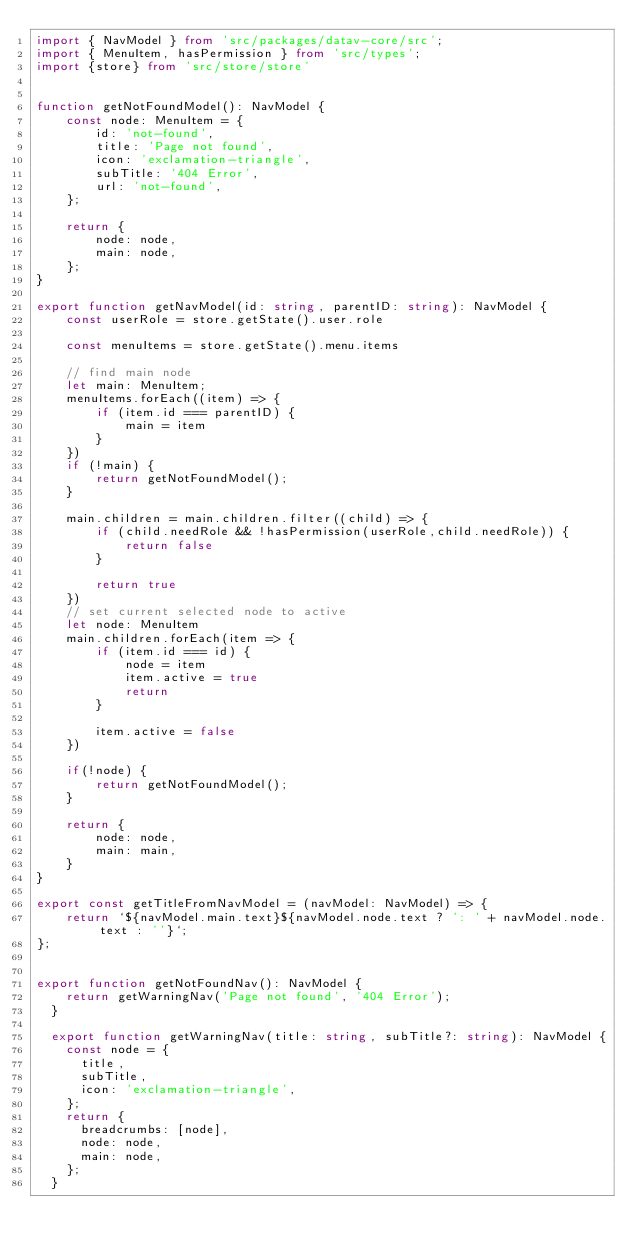Convert code to text. <code><loc_0><loc_0><loc_500><loc_500><_TypeScript_>import { NavModel } from 'src/packages/datav-core/src';
import { MenuItem, hasPermission } from 'src/types';
import {store} from 'src/store/store'


function getNotFoundModel(): NavModel {
    const node: MenuItem = {
        id: 'not-found',
        title: 'Page not found',
        icon: 'exclamation-triangle',
        subTitle: '404 Error',
        url: 'not-found',
    };

    return {
        node: node,
        main: node,
    };
}

export function getNavModel(id: string, parentID: string): NavModel {
    const userRole = store.getState().user.role

    const menuItems = store.getState().menu.items

    // find main node
    let main: MenuItem;
    menuItems.forEach((item) => {
        if (item.id === parentID) {
            main = item
        }
    })
    if (!main) {
        return getNotFoundModel();
    }

    main.children = main.children.filter((child) => {
        if (child.needRole && !hasPermission(userRole,child.needRole)) {
            return false
        }

        return true
    })
    // set current selected node to active
    let node: MenuItem
    main.children.forEach(item => {
        if (item.id === id) {
            node = item
            item.active = true
            return
        } 
        
        item.active = false
    })

    if(!node) {
        return getNotFoundModel();
    }
    
    return {
        node: node,
        main: main,
    }
}

export const getTitleFromNavModel = (navModel: NavModel) => {
    return `${navModel.main.text}${navModel.node.text ? ': ' + navModel.node.text : ''}`;
};


export function getNotFoundNav(): NavModel {
    return getWarningNav('Page not found', '404 Error');
  }
  
  export function getWarningNav(title: string, subTitle?: string): NavModel {
    const node = {
      title,
      subTitle,
      icon: 'exclamation-triangle',
    };
    return {
      breadcrumbs: [node],
      node: node,
      main: node,
    };
  }</code> 